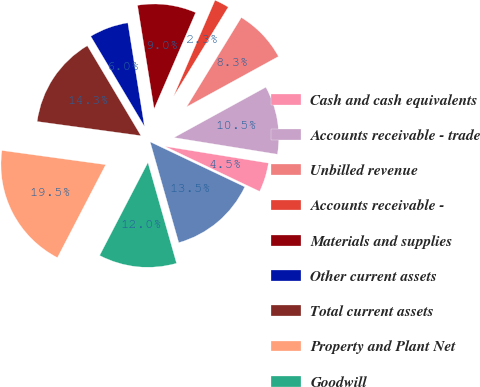<chart> <loc_0><loc_0><loc_500><loc_500><pie_chart><fcel>Cash and cash equivalents<fcel>Accounts receivable - trade<fcel>Unbilled revenue<fcel>Accounts receivable -<fcel>Materials and supplies<fcel>Other current assets<fcel>Total current assets<fcel>Property and Plant Net<fcel>Goodwill<fcel>Regulatory assets<nl><fcel>4.52%<fcel>10.53%<fcel>8.27%<fcel>2.26%<fcel>9.02%<fcel>6.02%<fcel>14.28%<fcel>19.54%<fcel>12.03%<fcel>13.53%<nl></chart> 